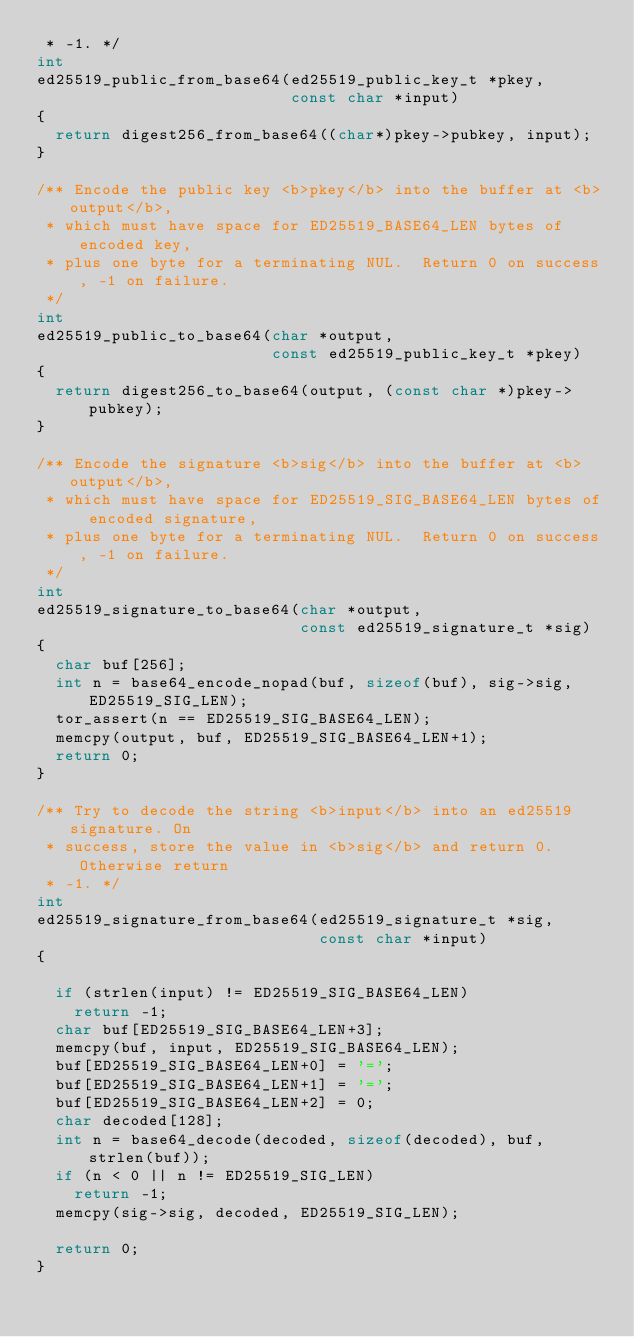Convert code to text. <code><loc_0><loc_0><loc_500><loc_500><_C_> * -1. */
int
ed25519_public_from_base64(ed25519_public_key_t *pkey,
                           const char *input)
{
  return digest256_from_base64((char*)pkey->pubkey, input);
}

/** Encode the public key <b>pkey</b> into the buffer at <b>output</b>,
 * which must have space for ED25519_BASE64_LEN bytes of encoded key,
 * plus one byte for a terminating NUL.  Return 0 on success, -1 on failure.
 */
int
ed25519_public_to_base64(char *output,
                         const ed25519_public_key_t *pkey)
{
  return digest256_to_base64(output, (const char *)pkey->pubkey);
}

/** Encode the signature <b>sig</b> into the buffer at <b>output</b>,
 * which must have space for ED25519_SIG_BASE64_LEN bytes of encoded signature,
 * plus one byte for a terminating NUL.  Return 0 on success, -1 on failure.
 */
int
ed25519_signature_to_base64(char *output,
                            const ed25519_signature_t *sig)
{
  char buf[256];
  int n = base64_encode_nopad(buf, sizeof(buf), sig->sig, ED25519_SIG_LEN);
  tor_assert(n == ED25519_SIG_BASE64_LEN);
  memcpy(output, buf, ED25519_SIG_BASE64_LEN+1);
  return 0;
}

/** Try to decode the string <b>input</b> into an ed25519 signature. On
 * success, store the value in <b>sig</b> and return 0. Otherwise return
 * -1. */
int
ed25519_signature_from_base64(ed25519_signature_t *sig,
                              const char *input)
{

  if (strlen(input) != ED25519_SIG_BASE64_LEN)
    return -1;
  char buf[ED25519_SIG_BASE64_LEN+3];
  memcpy(buf, input, ED25519_SIG_BASE64_LEN);
  buf[ED25519_SIG_BASE64_LEN+0] = '=';
  buf[ED25519_SIG_BASE64_LEN+1] = '=';
  buf[ED25519_SIG_BASE64_LEN+2] = 0;
  char decoded[128];
  int n = base64_decode(decoded, sizeof(decoded), buf, strlen(buf));
  if (n < 0 || n != ED25519_SIG_LEN)
    return -1;
  memcpy(sig->sig, decoded, ED25519_SIG_LEN);

  return 0;
}

</code> 